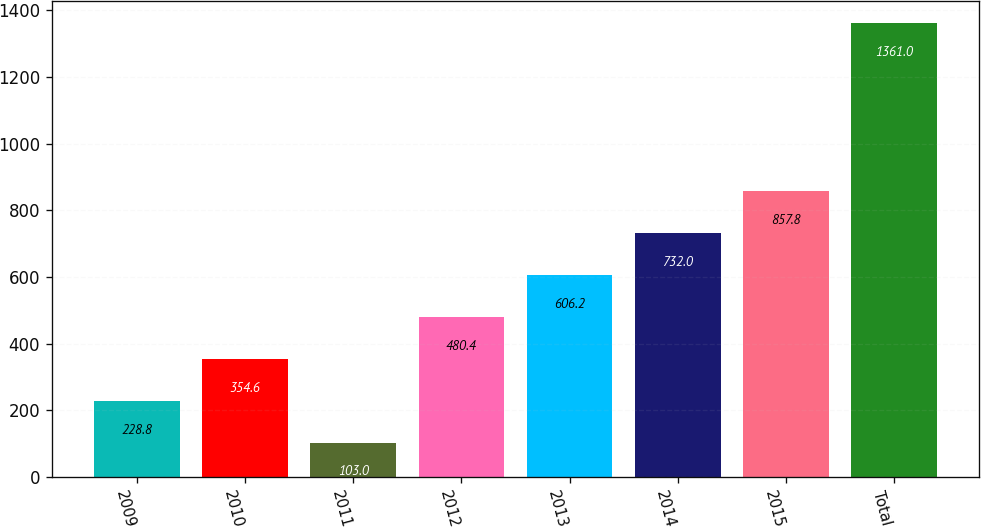Convert chart to OTSL. <chart><loc_0><loc_0><loc_500><loc_500><bar_chart><fcel>2009<fcel>2010<fcel>2011<fcel>2012<fcel>2013<fcel>2014<fcel>2015<fcel>Total<nl><fcel>228.8<fcel>354.6<fcel>103<fcel>480.4<fcel>606.2<fcel>732<fcel>857.8<fcel>1361<nl></chart> 